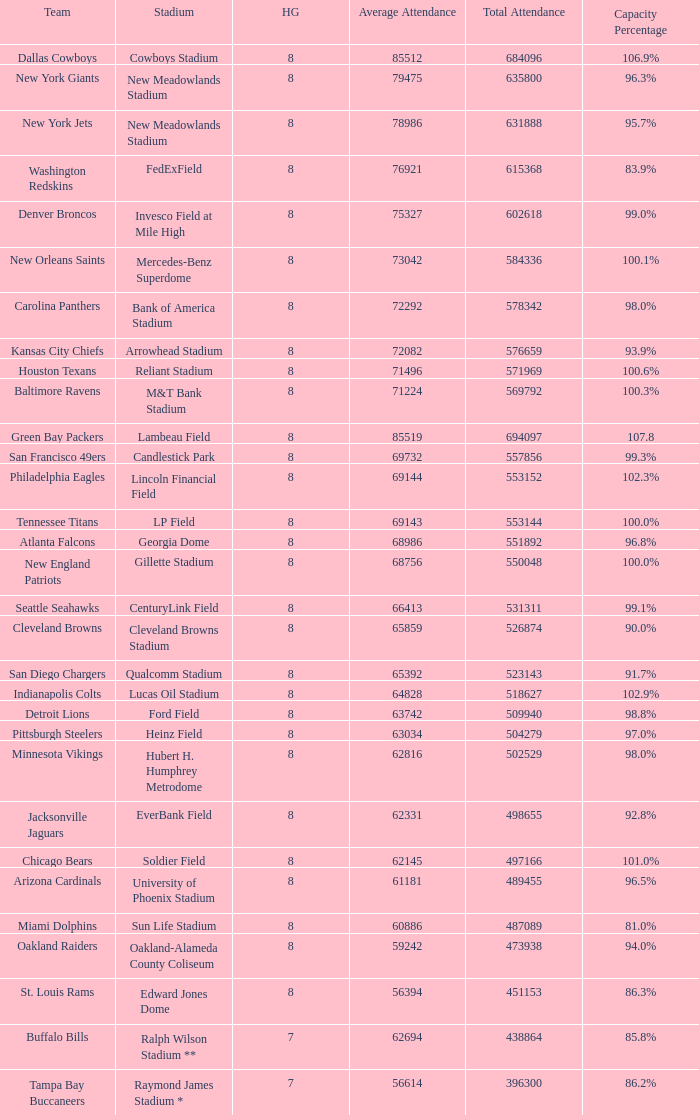What is the capacity percentage when the total attendance is 509940? 98.8%. 